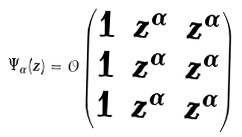Convert formula to latex. <formula><loc_0><loc_0><loc_500><loc_500>\Psi _ { \alpha } ( z ) = \mathcal { O } \begin{pmatrix} 1 & z ^ { \alpha } & z ^ { \alpha } \\ 1 & z ^ { \alpha } & z ^ { \alpha } \\ 1 & z ^ { \alpha } & z ^ { \alpha } \end{pmatrix}</formula> 